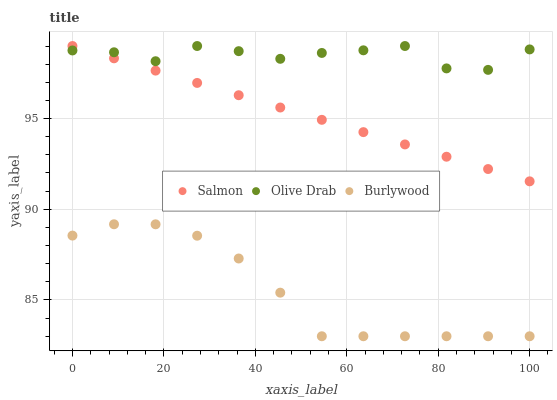Does Burlywood have the minimum area under the curve?
Answer yes or no. Yes. Does Olive Drab have the maximum area under the curve?
Answer yes or no. Yes. Does Salmon have the minimum area under the curve?
Answer yes or no. No. Does Salmon have the maximum area under the curve?
Answer yes or no. No. Is Salmon the smoothest?
Answer yes or no. Yes. Is Olive Drab the roughest?
Answer yes or no. Yes. Is Olive Drab the smoothest?
Answer yes or no. No. Is Salmon the roughest?
Answer yes or no. No. Does Burlywood have the lowest value?
Answer yes or no. Yes. Does Salmon have the lowest value?
Answer yes or no. No. Does Olive Drab have the highest value?
Answer yes or no. Yes. Is Burlywood less than Olive Drab?
Answer yes or no. Yes. Is Salmon greater than Burlywood?
Answer yes or no. Yes. Does Olive Drab intersect Salmon?
Answer yes or no. Yes. Is Olive Drab less than Salmon?
Answer yes or no. No. Is Olive Drab greater than Salmon?
Answer yes or no. No. Does Burlywood intersect Olive Drab?
Answer yes or no. No. 